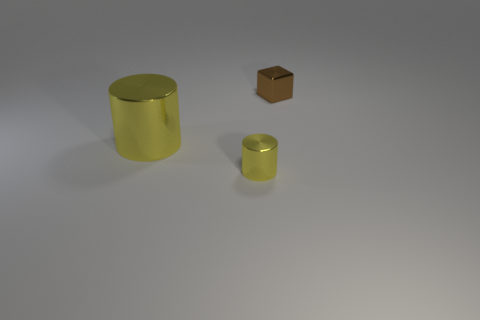What could be the possible uses for these items in the image? These objects could serve various purposes. The large yellow cylinder might be a decorative piece or a storage container, possibly for holding items like umbrellas or rolled-up posters. The small golden cylinder could be a container for smaller items such as pens or coins, perhaps sitting on someone's desk as an organizer. Lastly, the brown cube might be a paperweight, a decorative block, or a child's plaything. Its use could largely depend on its material and weight. 